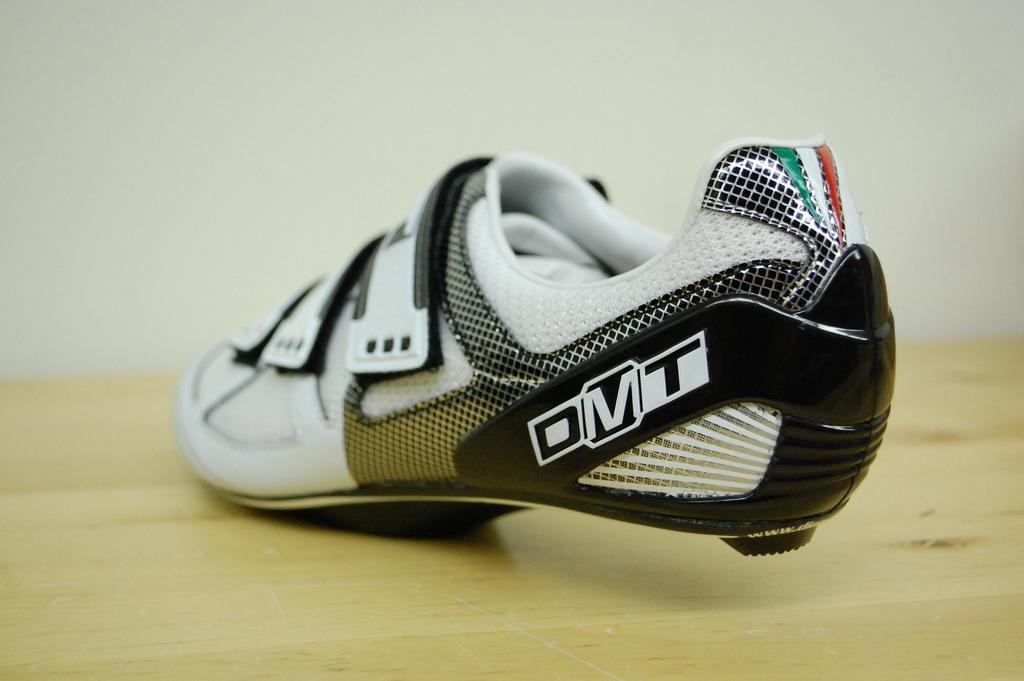Can you describe this image briefly? In this picture we can see a shoe on the wooden surface and in the background we can see the wall. 